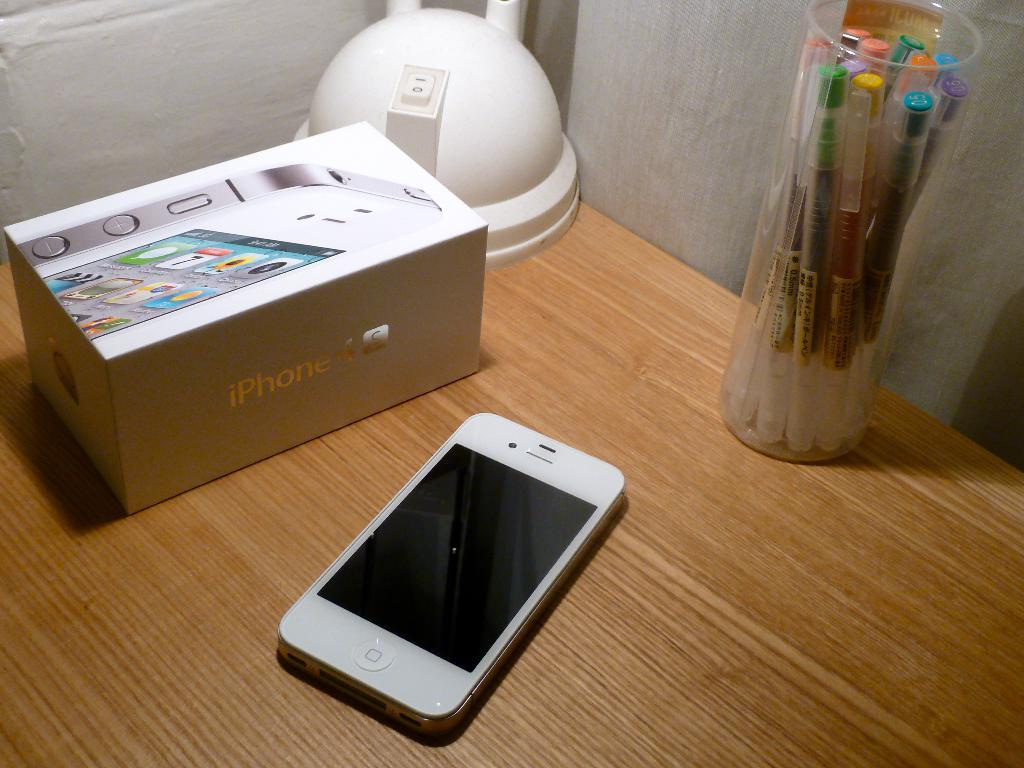<image>
Provide a brief description of the given image. a white cell phone with a box reading iPHONE on a wood desk 